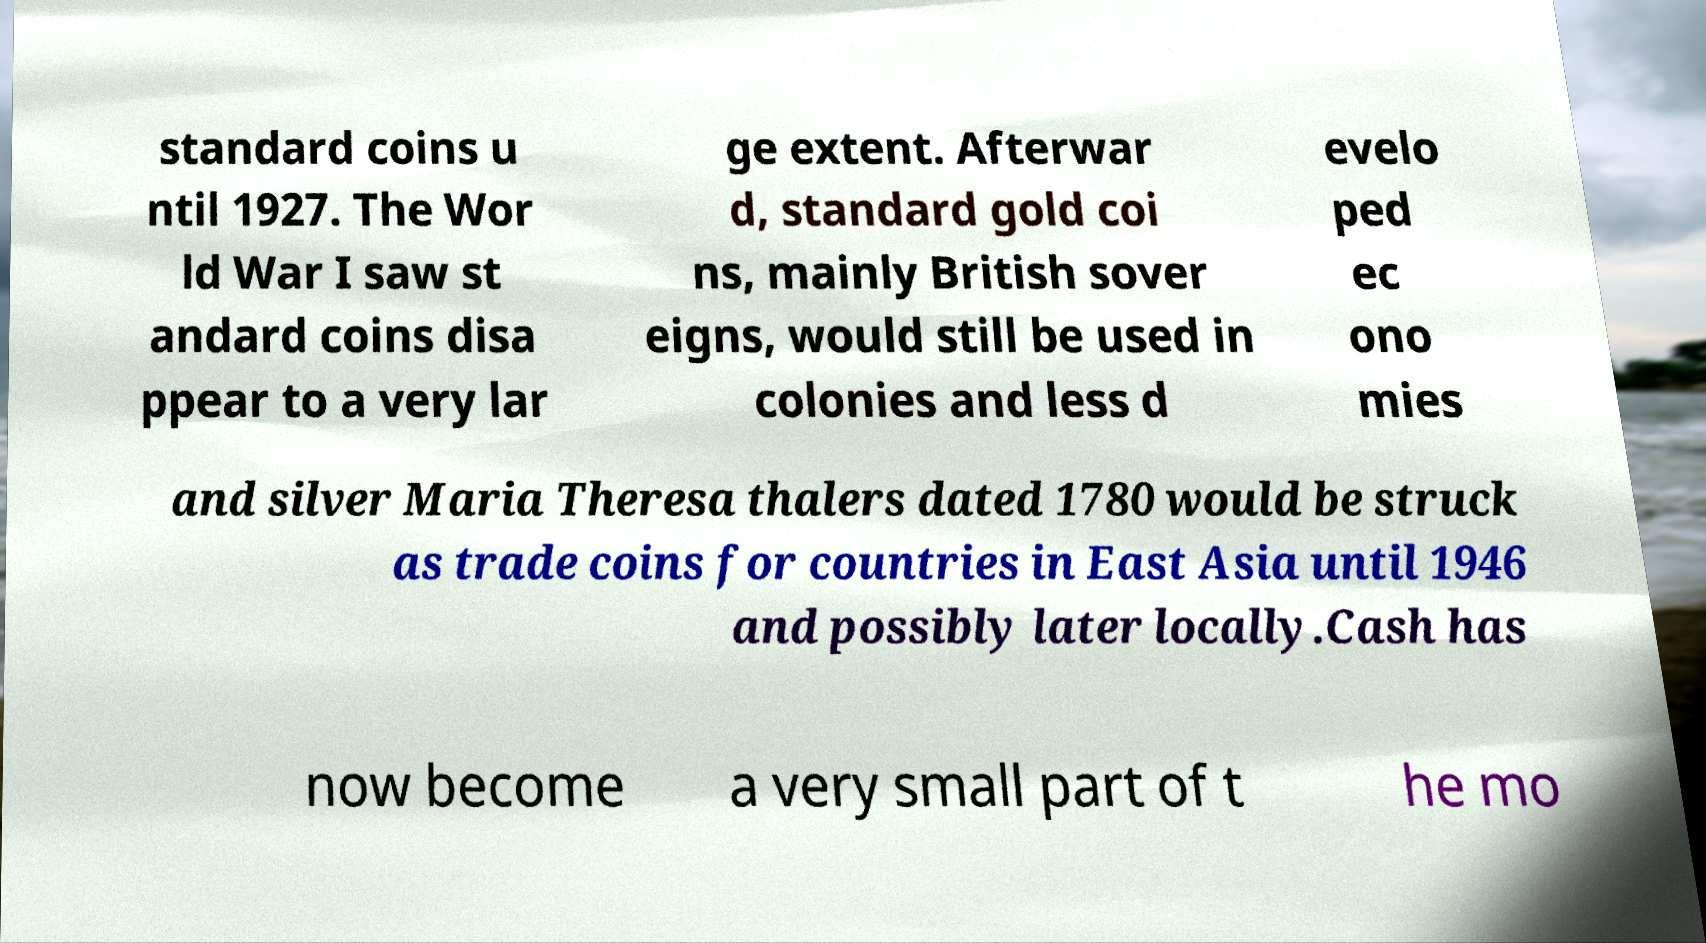Can you read and provide the text displayed in the image?This photo seems to have some interesting text. Can you extract and type it out for me? standard coins u ntil 1927. The Wor ld War I saw st andard coins disa ppear to a very lar ge extent. Afterwar d, standard gold coi ns, mainly British sover eigns, would still be used in colonies and less d evelo ped ec ono mies and silver Maria Theresa thalers dated 1780 would be struck as trade coins for countries in East Asia until 1946 and possibly later locally.Cash has now become a very small part of t he mo 